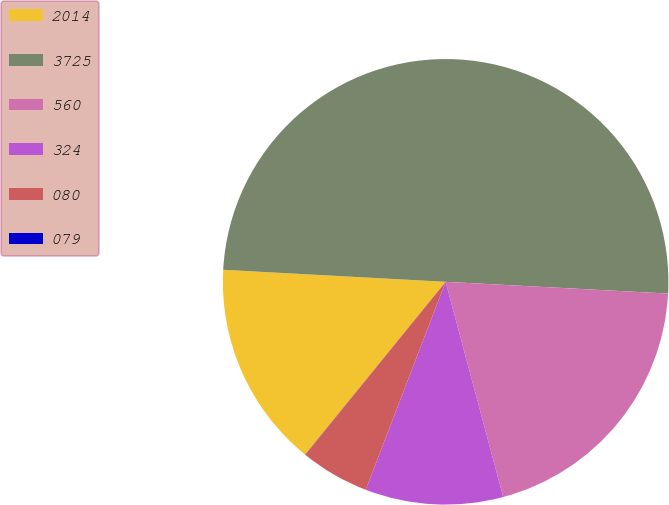Convert chart to OTSL. <chart><loc_0><loc_0><loc_500><loc_500><pie_chart><fcel>2014<fcel>3725<fcel>560<fcel>324<fcel>080<fcel>079<nl><fcel>15.0%<fcel>49.98%<fcel>20.0%<fcel>10.0%<fcel>5.01%<fcel>0.01%<nl></chart> 